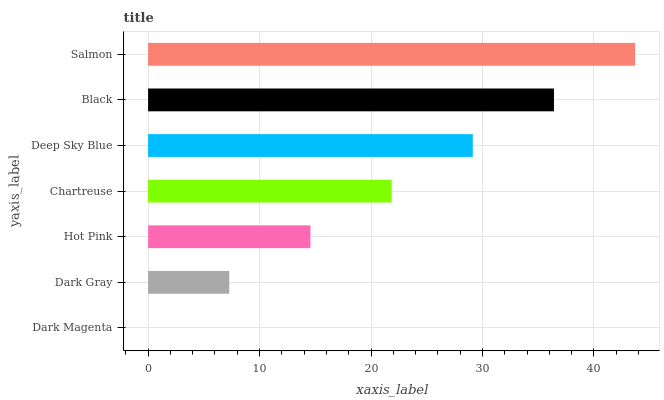Is Dark Magenta the minimum?
Answer yes or no. Yes. Is Salmon the maximum?
Answer yes or no. Yes. Is Dark Gray the minimum?
Answer yes or no. No. Is Dark Gray the maximum?
Answer yes or no. No. Is Dark Gray greater than Dark Magenta?
Answer yes or no. Yes. Is Dark Magenta less than Dark Gray?
Answer yes or no. Yes. Is Dark Magenta greater than Dark Gray?
Answer yes or no. No. Is Dark Gray less than Dark Magenta?
Answer yes or no. No. Is Chartreuse the high median?
Answer yes or no. Yes. Is Chartreuse the low median?
Answer yes or no. Yes. Is Black the high median?
Answer yes or no. No. Is Dark Gray the low median?
Answer yes or no. No. 